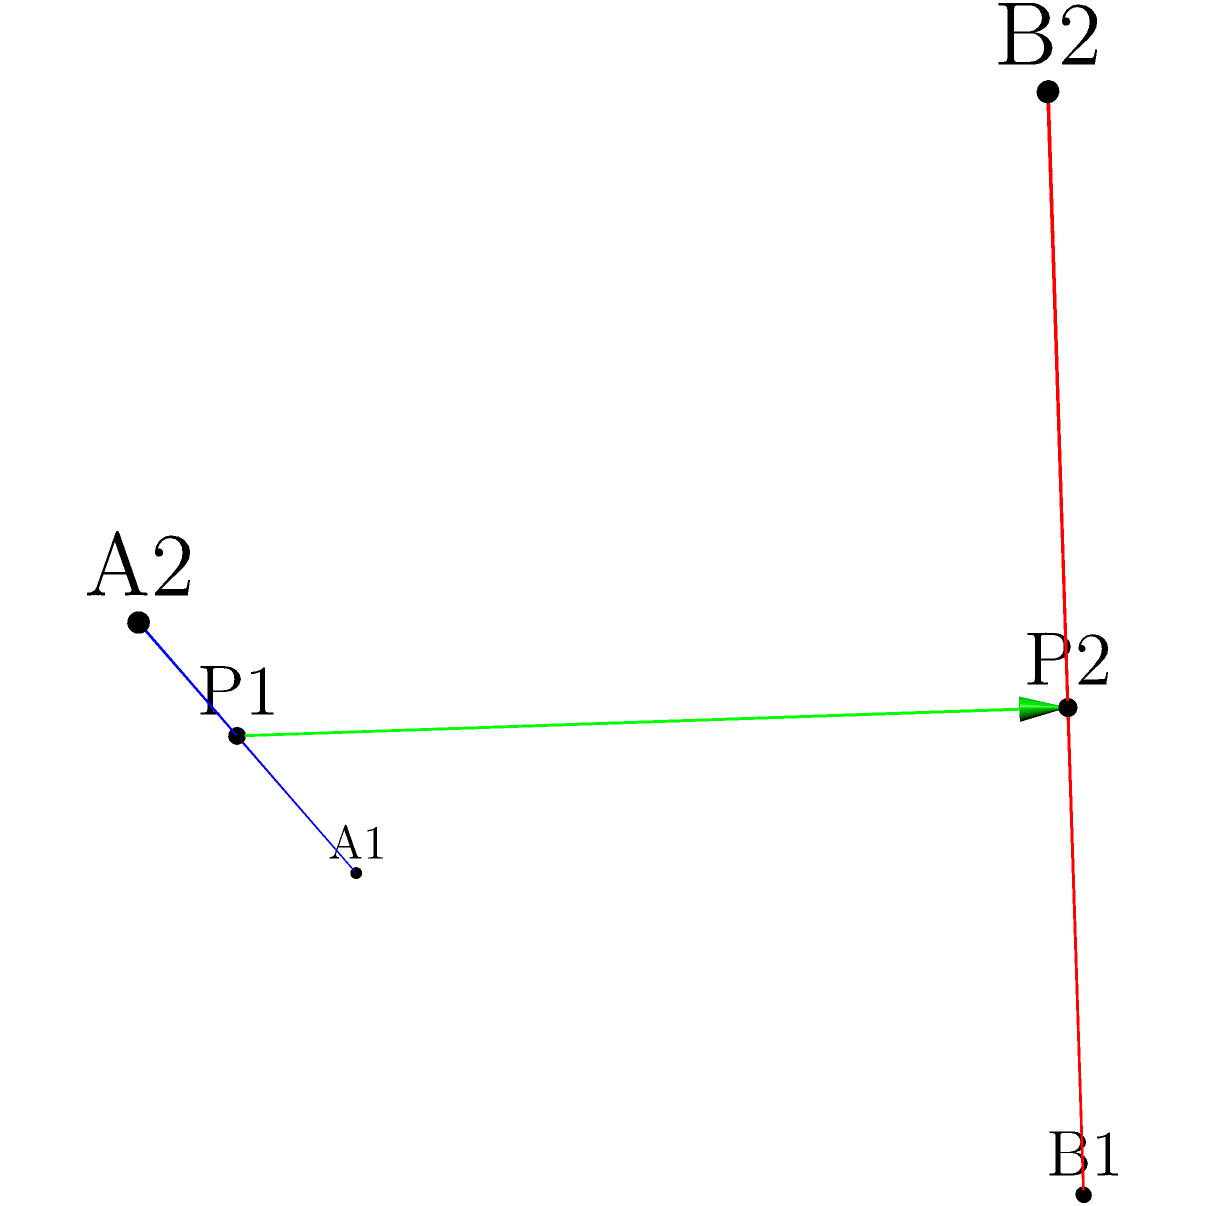At a Pink Floyd reunion concert, two laser beams are used in the light show, represented by skew lines in 3D space. The blue line passes through points (0,0,0) and (3,1,2), while the red line passes through (1,2,0) and (2,2,3). Calculate the shortest distance between these two laser beams, ensuring the psychedelic visual effect is optimized without the beams intersecting. Let's approach this step-by-step, using vector algebra:

1) Let's define vectors $\mathbf{a}$ and $\mathbf{b}$ along the two lines:
   $\mathbf{a} = (3,1,2) - (0,0,0) = (3,1,2)$
   $\mathbf{b} = (2,2,3) - (1,2,0) = (1,0,3)$

2) The direction of the shortest line between the skew lines is perpendicular to both $\mathbf{a}$ and $\mathbf{b}$. We can find this direction using the cross product:
   $\mathbf{n} = \mathbf{a} \times \mathbf{b} = (3,1,2) \times (1,0,3) = (3,-7,1)$

3) Now, let's parameterize the two lines:
   Line 1: $\mathbf{r_1}(s) = (0,0,0) + s(3,1,2)$
   Line 2: $\mathbf{r_2}(t) = (1,2,0) + t(1,0,3)$

4) The vector between any two points on these lines is:
   $\mathbf{w}(s,t) = \mathbf{r_2}(t) - \mathbf{r_1}(s) = (1,2,0) + t(1,0,3) - s(3,1,2)$

5) For the shortest distance, this vector should be perpendicular to both lines. We can express this using dot products:
   $\mathbf{w}(s,t) \cdot \mathbf{a} = 0$ and $\mathbf{w}(s,t) \cdot \mathbf{b} = 0$

6) This gives us two equations:
   $(1-3s+t, 2-s, 3t-2s) \cdot (3,1,2) = 0$
   $(1-3s+t, 2-s, 3t-2s) \cdot (1,0,3) = 0$

7) Solving these equations:
   $3-9s+3t+2-s+6t-4s = 0$
   $1-3s+t+9t-6s = 0$

8) Simplifying:
   $5-14s+9t = 0$
   $1-9s+10t = 0$

9) Solving this system of equations:
   $s = \frac{95}{131}$ and $t = \frac{86}{131}$

10) Plugging these back into $\mathbf{w}(s,t)$:
    $\mathbf{w}(\frac{95}{131},\frac{86}{131}) = (\frac{-198}{131},\frac{-95}{131},\frac{168}{131})$

11) The magnitude of this vector is the shortest distance:
    $d = \sqrt{(\frac{-198}{131})^2 + (\frac{-95}{131})^2 + (\frac{168}{131})^2} = \frac{\sqrt{73626}}{131} \approx 2.07$
Answer: $\frac{\sqrt{73626}}{131}$ units (approximately 2.07 units) 